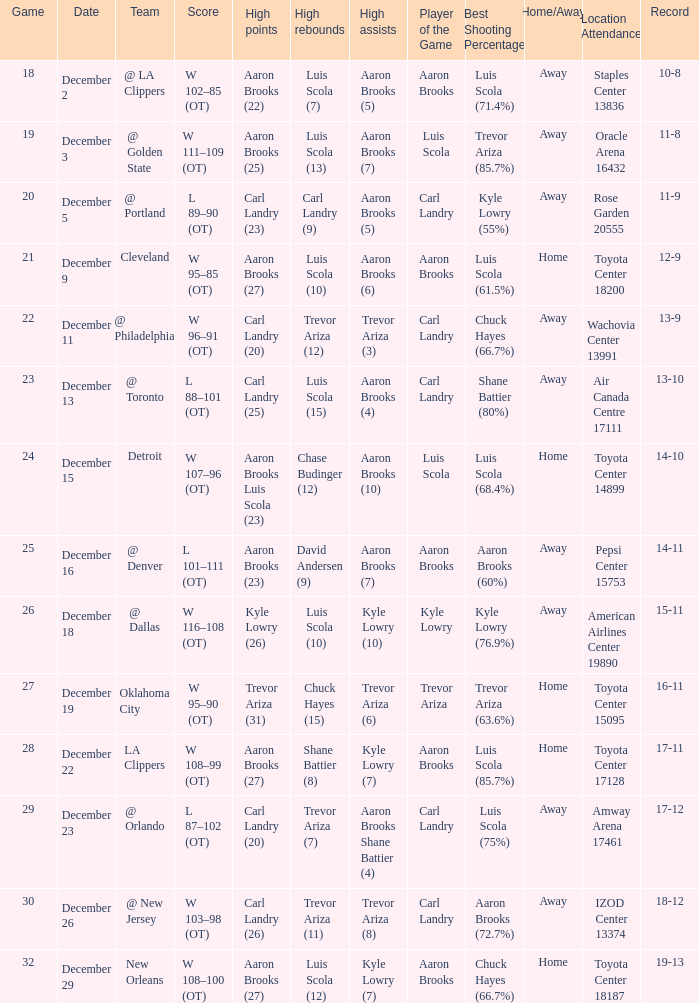What's the end score of the game where Shane Battier (8) did the high rebounds? W 108–99 (OT). 